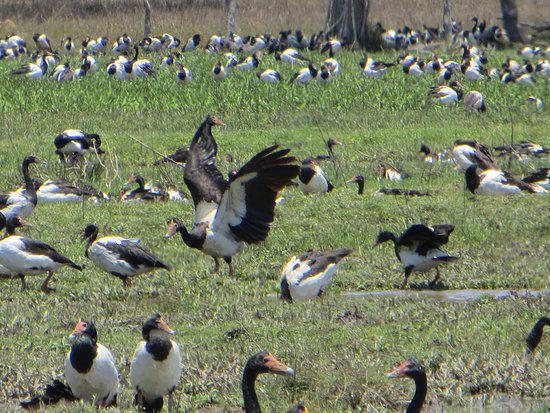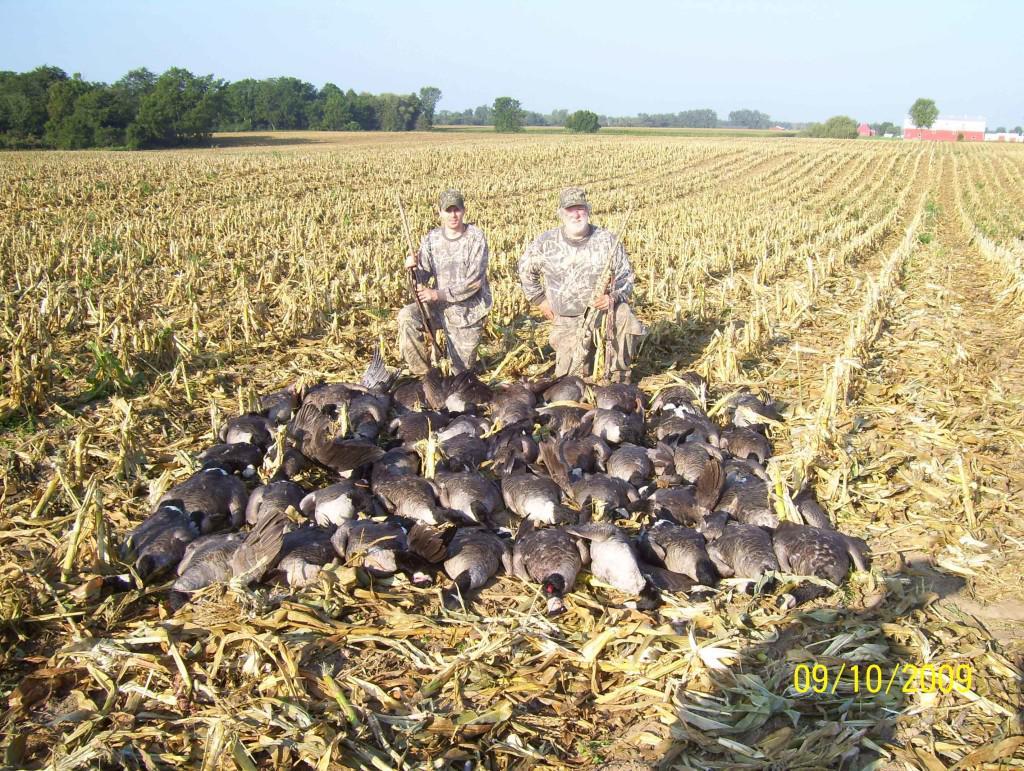The first image is the image on the left, the second image is the image on the right. Examine the images to the left and right. Is the description "There are no more than 4 animals in one of the images." accurate? Answer yes or no. No. The first image is the image on the left, the second image is the image on the right. Analyze the images presented: Is the assertion "There is at least one human pictured with a group of birds." valid? Answer yes or no. Yes. 